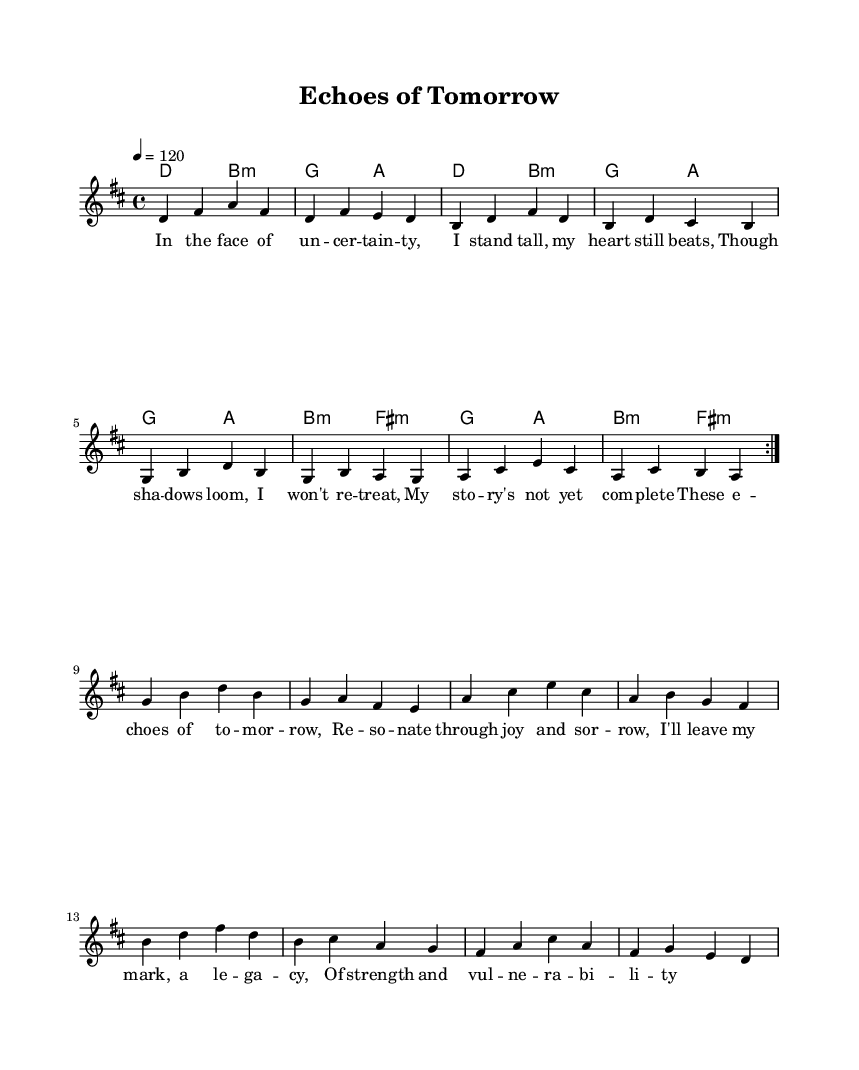What is the key signature of this music? The key signature is D major, which has two sharps (F# and C#).
Answer: D major What is the time signature of this music? The time signature is 4/4, indicating four beats per measure.
Answer: 4/4 What is the tempo marking of this piece? The tempo marking is "4 = 120," which indicates a moderate tempo of 120 beats per minute.
Answer: 120 How many repeats are indicated in the melody section? The melody section contains a repeat indication (volta) which instructs the performer to play the section twice.
Answer: 2 What is the first lyric line of the song? The first lyric line is "In the face of uncertainty," which introduces the emotional theme of the ballad.
Answer: In the face of uncertainty Which chord follows the first two measures of the melody? The chord that follows the first two measures of the melody is B minor, as indicated in the chord changes.
Answer: B minor What is a distinctive feature of this music in relation to punk themes? A distinctive feature is the exploration of mortality and legacy, which is a common theme in melodic punk ballads.
Answer: Mortality and legacy 